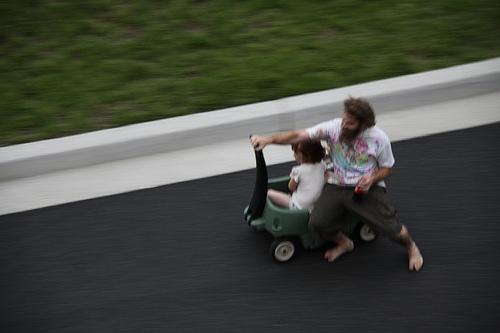<image>
Is there a person to the right of the wagon? No. The person is not to the right of the wagon. The horizontal positioning shows a different relationship. 